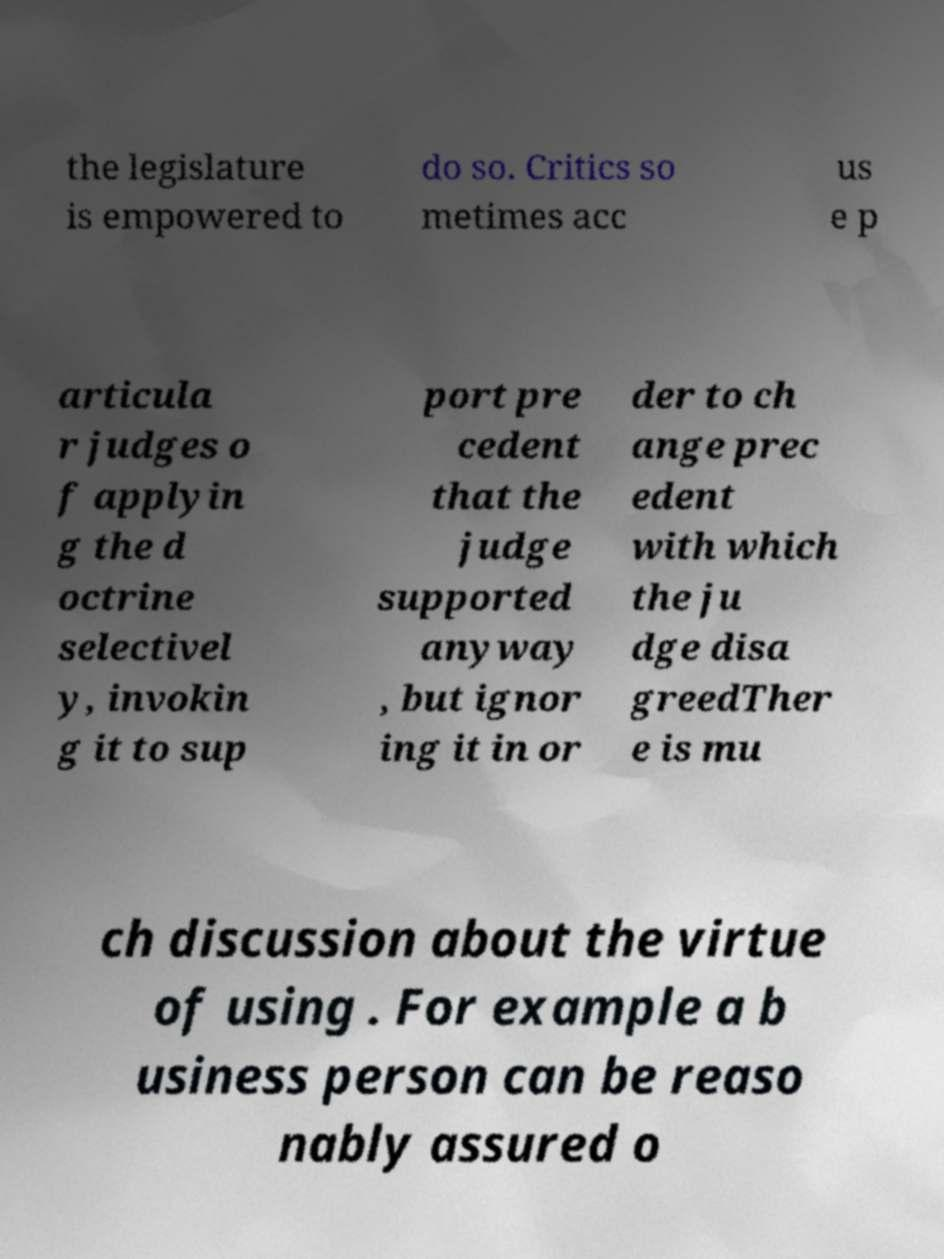For documentation purposes, I need the text within this image transcribed. Could you provide that? the legislature is empowered to do so. Critics so metimes acc us e p articula r judges o f applyin g the d octrine selectivel y, invokin g it to sup port pre cedent that the judge supported anyway , but ignor ing it in or der to ch ange prec edent with which the ju dge disa greedTher e is mu ch discussion about the virtue of using . For example a b usiness person can be reaso nably assured o 